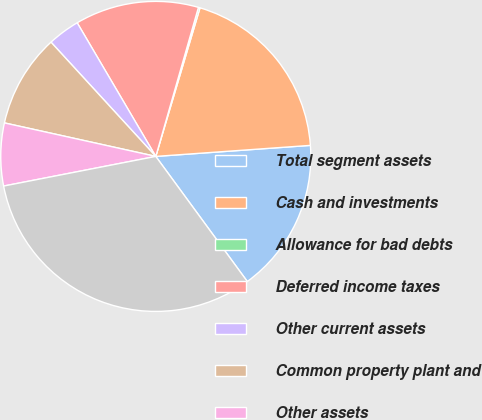Convert chart. <chart><loc_0><loc_0><loc_500><loc_500><pie_chart><fcel>Total segment assets<fcel>Cash and investments<fcel>Allowance for bad debts<fcel>Deferred income taxes<fcel>Other current assets<fcel>Common property plant and<fcel>Other assets<fcel>Consolidated total assets<nl><fcel>16.08%<fcel>19.26%<fcel>0.17%<fcel>12.9%<fcel>3.35%<fcel>9.72%<fcel>6.53%<fcel>31.99%<nl></chart> 